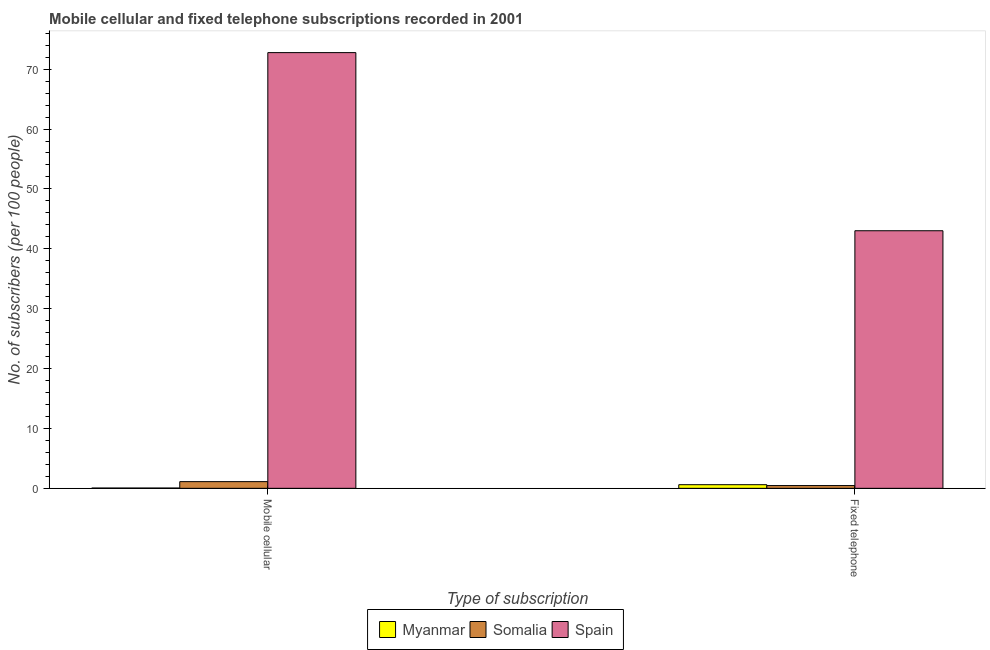Are the number of bars per tick equal to the number of legend labels?
Provide a short and direct response. Yes. What is the label of the 1st group of bars from the left?
Ensure brevity in your answer.  Mobile cellular. What is the number of mobile cellular subscribers in Somalia?
Your answer should be compact. 1.12. Across all countries, what is the maximum number of fixed telephone subscribers?
Your answer should be compact. 43.01. Across all countries, what is the minimum number of fixed telephone subscribers?
Your answer should be very brief. 0.46. In which country was the number of fixed telephone subscribers minimum?
Your answer should be very brief. Somalia. What is the total number of fixed telephone subscribers in the graph?
Offer a very short reply. 44.08. What is the difference between the number of fixed telephone subscribers in Myanmar and that in Somalia?
Make the answer very short. 0.14. What is the difference between the number of mobile cellular subscribers in Spain and the number of fixed telephone subscribers in Somalia?
Your response must be concise. 72.3. What is the average number of fixed telephone subscribers per country?
Keep it short and to the point. 14.69. What is the difference between the number of fixed telephone subscribers and number of mobile cellular subscribers in Spain?
Ensure brevity in your answer.  -29.75. In how many countries, is the number of mobile cellular subscribers greater than 66 ?
Ensure brevity in your answer.  1. What is the ratio of the number of mobile cellular subscribers in Somalia to that in Spain?
Give a very brief answer. 0.02. Is the number of fixed telephone subscribers in Myanmar less than that in Spain?
Offer a very short reply. Yes. In how many countries, is the number of mobile cellular subscribers greater than the average number of mobile cellular subscribers taken over all countries?
Provide a short and direct response. 1. What does the 3rd bar from the left in Fixed telephone represents?
Ensure brevity in your answer.  Spain. What does the 1st bar from the right in Fixed telephone represents?
Your response must be concise. Spain. Are all the bars in the graph horizontal?
Provide a succinct answer. No. Does the graph contain grids?
Your answer should be very brief. No. How are the legend labels stacked?
Offer a terse response. Horizontal. What is the title of the graph?
Your answer should be compact. Mobile cellular and fixed telephone subscriptions recorded in 2001. Does "Lao PDR" appear as one of the legend labels in the graph?
Provide a succinct answer. No. What is the label or title of the X-axis?
Your response must be concise. Type of subscription. What is the label or title of the Y-axis?
Offer a very short reply. No. of subscribers (per 100 people). What is the No. of subscribers (per 100 people) of Myanmar in Mobile cellular?
Provide a succinct answer. 0.05. What is the No. of subscribers (per 100 people) of Somalia in Mobile cellular?
Provide a succinct answer. 1.12. What is the No. of subscribers (per 100 people) in Spain in Mobile cellular?
Your answer should be compact. 72.76. What is the No. of subscribers (per 100 people) of Myanmar in Fixed telephone?
Provide a succinct answer. 0.6. What is the No. of subscribers (per 100 people) in Somalia in Fixed telephone?
Provide a short and direct response. 0.46. What is the No. of subscribers (per 100 people) in Spain in Fixed telephone?
Your answer should be very brief. 43.01. Across all Type of subscription, what is the maximum No. of subscribers (per 100 people) in Myanmar?
Keep it short and to the point. 0.6. Across all Type of subscription, what is the maximum No. of subscribers (per 100 people) in Somalia?
Ensure brevity in your answer.  1.12. Across all Type of subscription, what is the maximum No. of subscribers (per 100 people) of Spain?
Make the answer very short. 72.76. Across all Type of subscription, what is the minimum No. of subscribers (per 100 people) in Myanmar?
Provide a short and direct response. 0.05. Across all Type of subscription, what is the minimum No. of subscribers (per 100 people) in Somalia?
Offer a terse response. 0.46. Across all Type of subscription, what is the minimum No. of subscribers (per 100 people) in Spain?
Provide a short and direct response. 43.01. What is the total No. of subscribers (per 100 people) of Myanmar in the graph?
Your answer should be compact. 0.65. What is the total No. of subscribers (per 100 people) of Somalia in the graph?
Ensure brevity in your answer.  1.58. What is the total No. of subscribers (per 100 people) in Spain in the graph?
Your answer should be compact. 115.78. What is the difference between the No. of subscribers (per 100 people) in Myanmar in Mobile cellular and that in Fixed telephone?
Your answer should be very brief. -0.56. What is the difference between the No. of subscribers (per 100 people) of Somalia in Mobile cellular and that in Fixed telephone?
Offer a very short reply. 0.66. What is the difference between the No. of subscribers (per 100 people) of Spain in Mobile cellular and that in Fixed telephone?
Provide a succinct answer. 29.75. What is the difference between the No. of subscribers (per 100 people) in Myanmar in Mobile cellular and the No. of subscribers (per 100 people) in Somalia in Fixed telephone?
Ensure brevity in your answer.  -0.41. What is the difference between the No. of subscribers (per 100 people) in Myanmar in Mobile cellular and the No. of subscribers (per 100 people) in Spain in Fixed telephone?
Make the answer very short. -42.97. What is the difference between the No. of subscribers (per 100 people) of Somalia in Mobile cellular and the No. of subscribers (per 100 people) of Spain in Fixed telephone?
Your response must be concise. -41.9. What is the average No. of subscribers (per 100 people) of Myanmar per Type of subscription?
Offer a very short reply. 0.33. What is the average No. of subscribers (per 100 people) in Somalia per Type of subscription?
Give a very brief answer. 0.79. What is the average No. of subscribers (per 100 people) in Spain per Type of subscription?
Make the answer very short. 57.89. What is the difference between the No. of subscribers (per 100 people) of Myanmar and No. of subscribers (per 100 people) of Somalia in Mobile cellular?
Your answer should be very brief. -1.07. What is the difference between the No. of subscribers (per 100 people) in Myanmar and No. of subscribers (per 100 people) in Spain in Mobile cellular?
Provide a succinct answer. -72.72. What is the difference between the No. of subscribers (per 100 people) in Somalia and No. of subscribers (per 100 people) in Spain in Mobile cellular?
Your answer should be very brief. -71.65. What is the difference between the No. of subscribers (per 100 people) of Myanmar and No. of subscribers (per 100 people) of Somalia in Fixed telephone?
Give a very brief answer. 0.14. What is the difference between the No. of subscribers (per 100 people) in Myanmar and No. of subscribers (per 100 people) in Spain in Fixed telephone?
Your answer should be compact. -42.41. What is the difference between the No. of subscribers (per 100 people) in Somalia and No. of subscribers (per 100 people) in Spain in Fixed telephone?
Make the answer very short. -42.55. What is the ratio of the No. of subscribers (per 100 people) of Myanmar in Mobile cellular to that in Fixed telephone?
Give a very brief answer. 0.08. What is the ratio of the No. of subscribers (per 100 people) of Somalia in Mobile cellular to that in Fixed telephone?
Your answer should be compact. 2.43. What is the ratio of the No. of subscribers (per 100 people) of Spain in Mobile cellular to that in Fixed telephone?
Provide a short and direct response. 1.69. What is the difference between the highest and the second highest No. of subscribers (per 100 people) in Myanmar?
Keep it short and to the point. 0.56. What is the difference between the highest and the second highest No. of subscribers (per 100 people) in Somalia?
Your answer should be very brief. 0.66. What is the difference between the highest and the second highest No. of subscribers (per 100 people) in Spain?
Offer a very short reply. 29.75. What is the difference between the highest and the lowest No. of subscribers (per 100 people) of Myanmar?
Offer a terse response. 0.56. What is the difference between the highest and the lowest No. of subscribers (per 100 people) in Somalia?
Provide a succinct answer. 0.66. What is the difference between the highest and the lowest No. of subscribers (per 100 people) in Spain?
Provide a short and direct response. 29.75. 